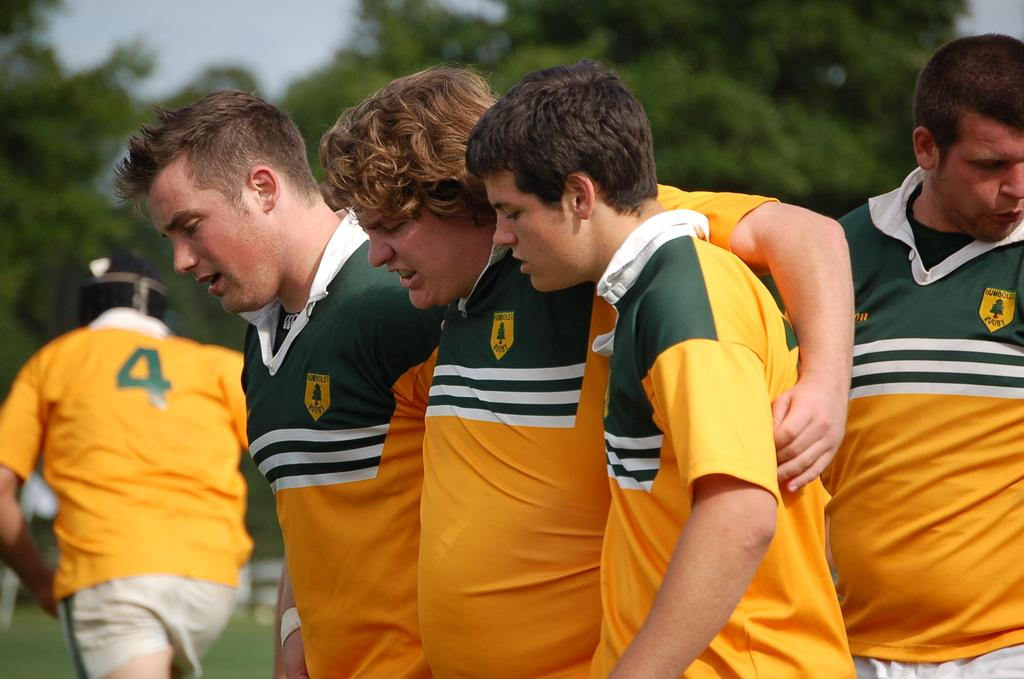<image>
Create a compact narrative representing the image presented. some players including one with the number 4 on it 